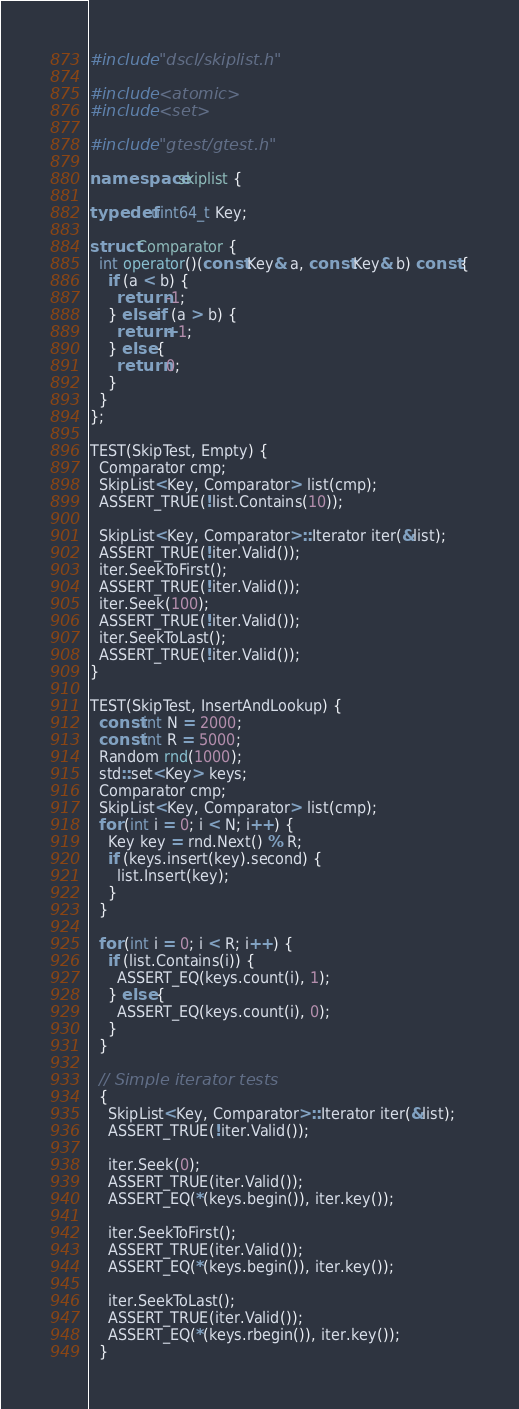Convert code to text. <code><loc_0><loc_0><loc_500><loc_500><_C++_>#include "dscl/skiplist.h"

#include <atomic>
#include <set>

#include "gtest/gtest.h"

namespace skiplist {

typedef uint64_t Key;

struct Comparator {
  int operator()(const Key& a, const Key& b) const {
    if (a < b) {
      return -1;
    } else if (a > b) {
      return +1;
    } else {
      return 0;
    }
  }
};

TEST(SkipTest, Empty) {
  Comparator cmp;
  SkipList<Key, Comparator> list(cmp);
  ASSERT_TRUE(!list.Contains(10));

  SkipList<Key, Comparator>::Iterator iter(&list);
  ASSERT_TRUE(!iter.Valid());
  iter.SeekToFirst();
  ASSERT_TRUE(!iter.Valid());
  iter.Seek(100);
  ASSERT_TRUE(!iter.Valid());
  iter.SeekToLast();
  ASSERT_TRUE(!iter.Valid());
}

TEST(SkipTest, InsertAndLookup) {
  const int N = 2000;
  const int R = 5000;
  Random rnd(1000);
  std::set<Key> keys;
  Comparator cmp;
  SkipList<Key, Comparator> list(cmp);
  for (int i = 0; i < N; i++) {
    Key key = rnd.Next() % R;
    if (keys.insert(key).second) {
      list.Insert(key);
    }
  }

  for (int i = 0; i < R; i++) {
    if (list.Contains(i)) {
      ASSERT_EQ(keys.count(i), 1);
    } else {
      ASSERT_EQ(keys.count(i), 0);
    }
  }

  // Simple iterator tests
  {
    SkipList<Key, Comparator>::Iterator iter(&list);
    ASSERT_TRUE(!iter.Valid());

    iter.Seek(0);
    ASSERT_TRUE(iter.Valid());
    ASSERT_EQ(*(keys.begin()), iter.key());

    iter.SeekToFirst();
    ASSERT_TRUE(iter.Valid());
    ASSERT_EQ(*(keys.begin()), iter.key());

    iter.SeekToLast();
    ASSERT_TRUE(iter.Valid());
    ASSERT_EQ(*(keys.rbegin()), iter.key());
  }
</code> 